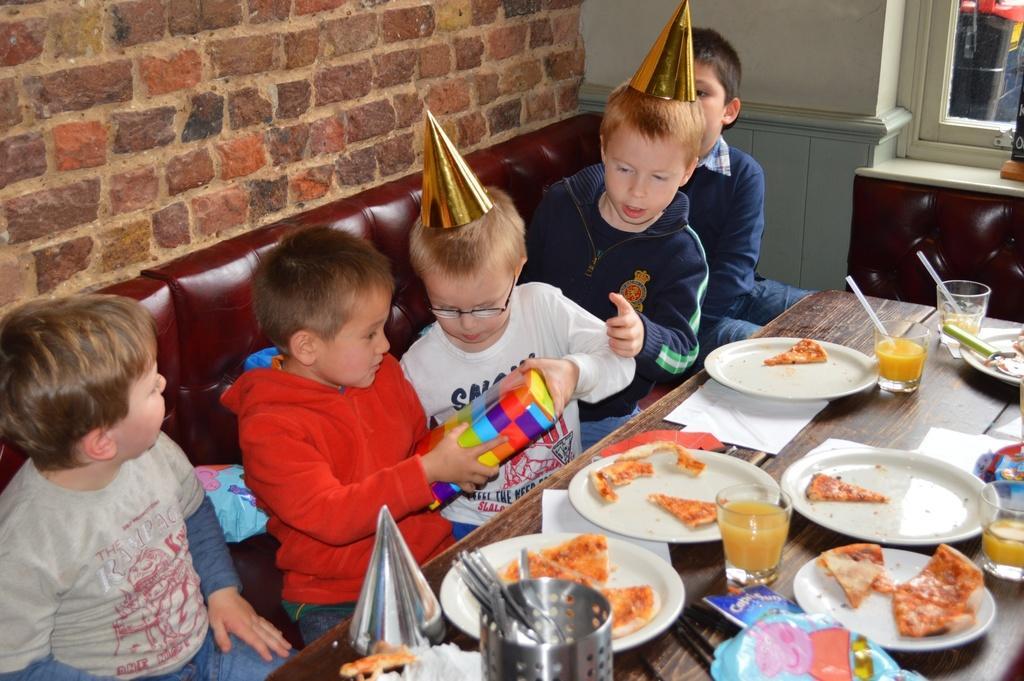Describe this image in one or two sentences. In this picture we can see five kids are sitting in front of a table, there are some plates, glasses of drinks, a spoon stand, tissue papers present on the table, we can see some food on these plates, there are spoons in this stand, these two kids are holding a box, on the left side there is a brick wall, we can see a window at the right top of the picture. 